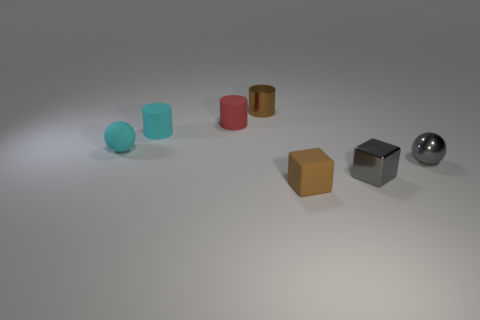Add 2 gray cubes. How many objects exist? 9 Subtract all blocks. How many objects are left? 5 Subtract 0 yellow balls. How many objects are left? 7 Subtract all large purple rubber cylinders. Subtract all brown matte things. How many objects are left? 6 Add 6 cyan matte cylinders. How many cyan matte cylinders are left? 7 Add 1 small blue balls. How many small blue balls exist? 1 